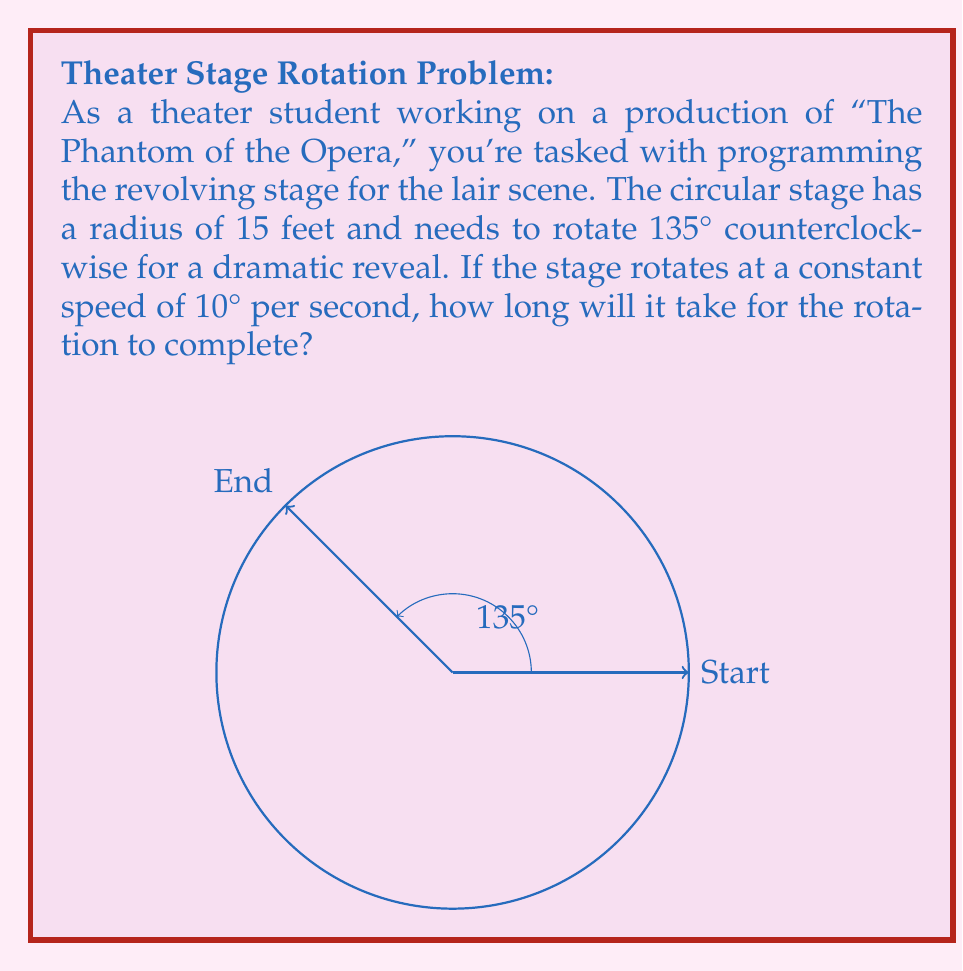Solve this math problem. Let's approach this step-by-step:

1) First, we need to identify the given information:
   - The stage needs to rotate 135° counterclockwise
   - The rotation speed is 10° per second

2) To find the time taken, we can use the formula:
   $$ \text{Time} = \frac{\text{Angular Displacement}}{\text{Angular Velocity}} $$

3) We have:
   - Angular Displacement = 135°
   - Angular Velocity = 10° per second

4) Plugging these values into our formula:
   $$ \text{Time} = \frac{135°}{10° \text{ per second}} $$

5) Simplify:
   $$ \text{Time} = 13.5 \text{ seconds} $$

Thus, it will take 13.5 seconds for the stage to complete its rotation.
Answer: 13.5 seconds 